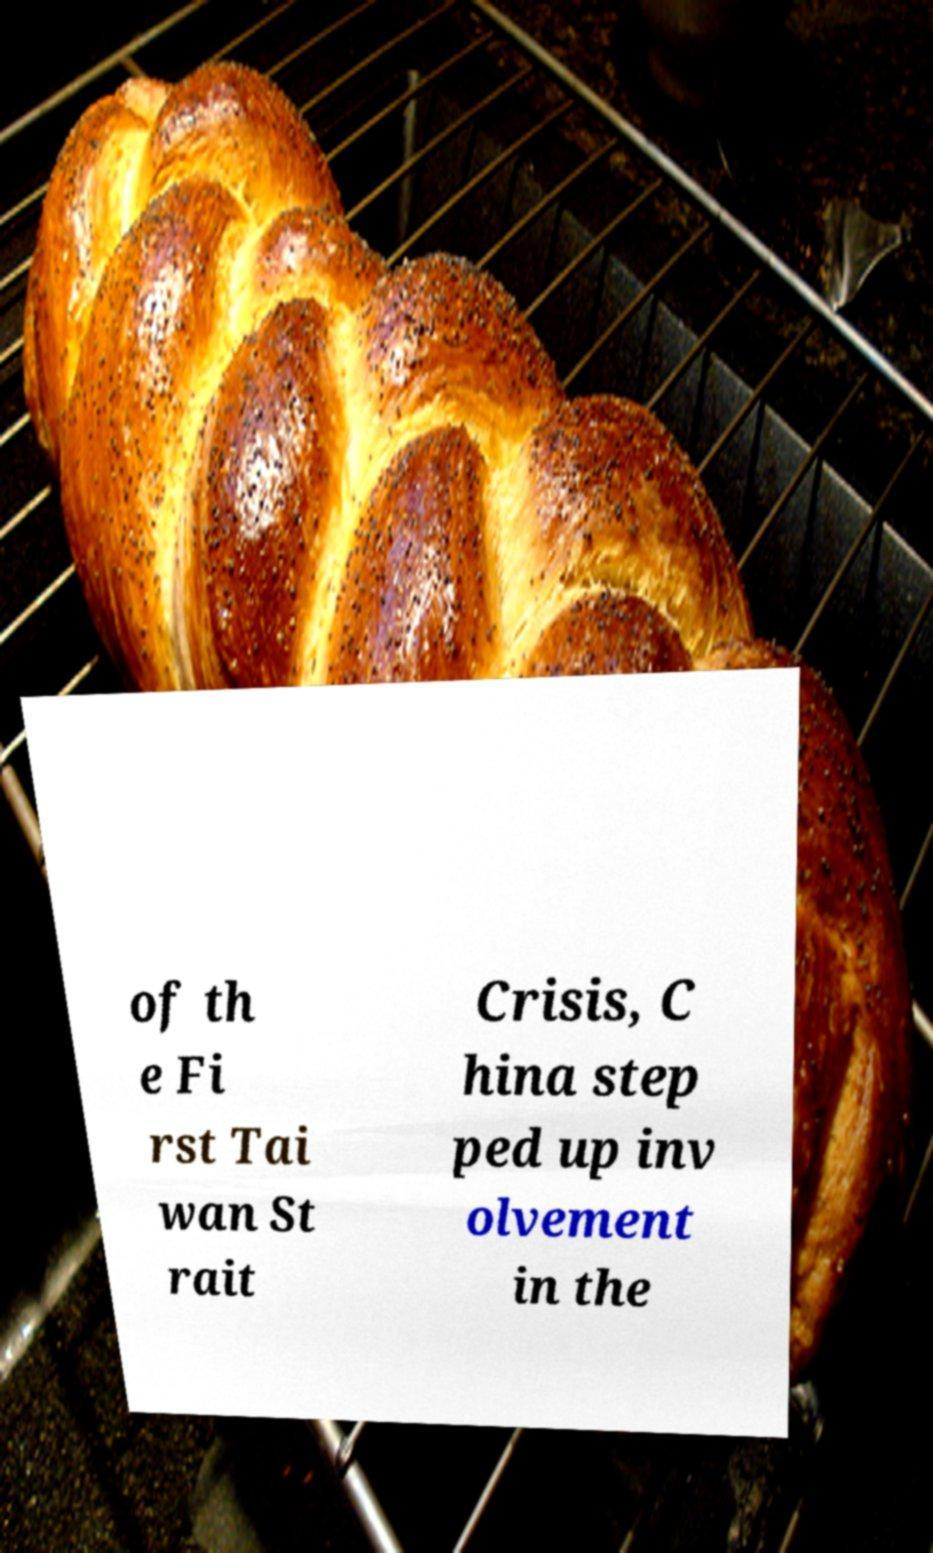Could you extract and type out the text from this image? of th e Fi rst Tai wan St rait Crisis, C hina step ped up inv olvement in the 